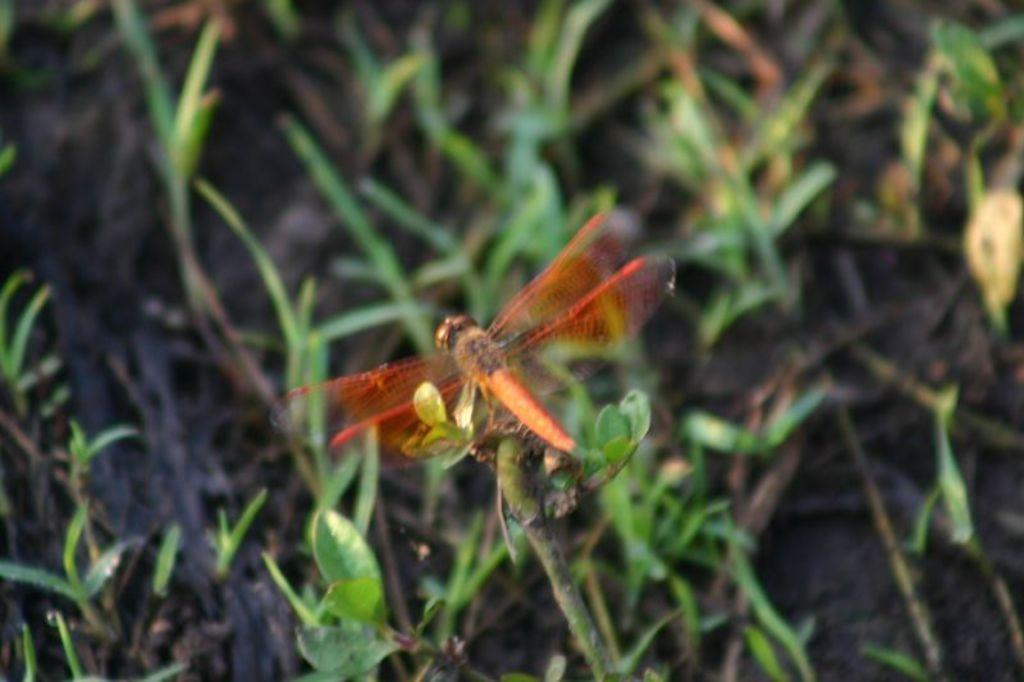What is present on the tree stem in the image? There is a fly on the tree stem in the image. What type of vegetation can be seen at the bottom of the image? Grass is visible at the bottom of the image. What time of day is depicted in the image? The time of day cannot be determined from the image, as there are no clues or indicators present. 